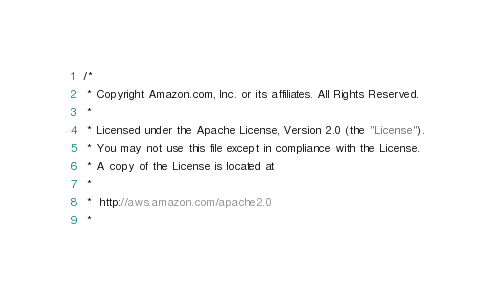Convert code to text. <code><loc_0><loc_0><loc_500><loc_500><_C#_>/*
 * Copyright Amazon.com, Inc. or its affiliates. All Rights Reserved.
 * 
 * Licensed under the Apache License, Version 2.0 (the "License").
 * You may not use this file except in compliance with the License.
 * A copy of the License is located at
 * 
 *  http://aws.amazon.com/apache2.0
 * </code> 